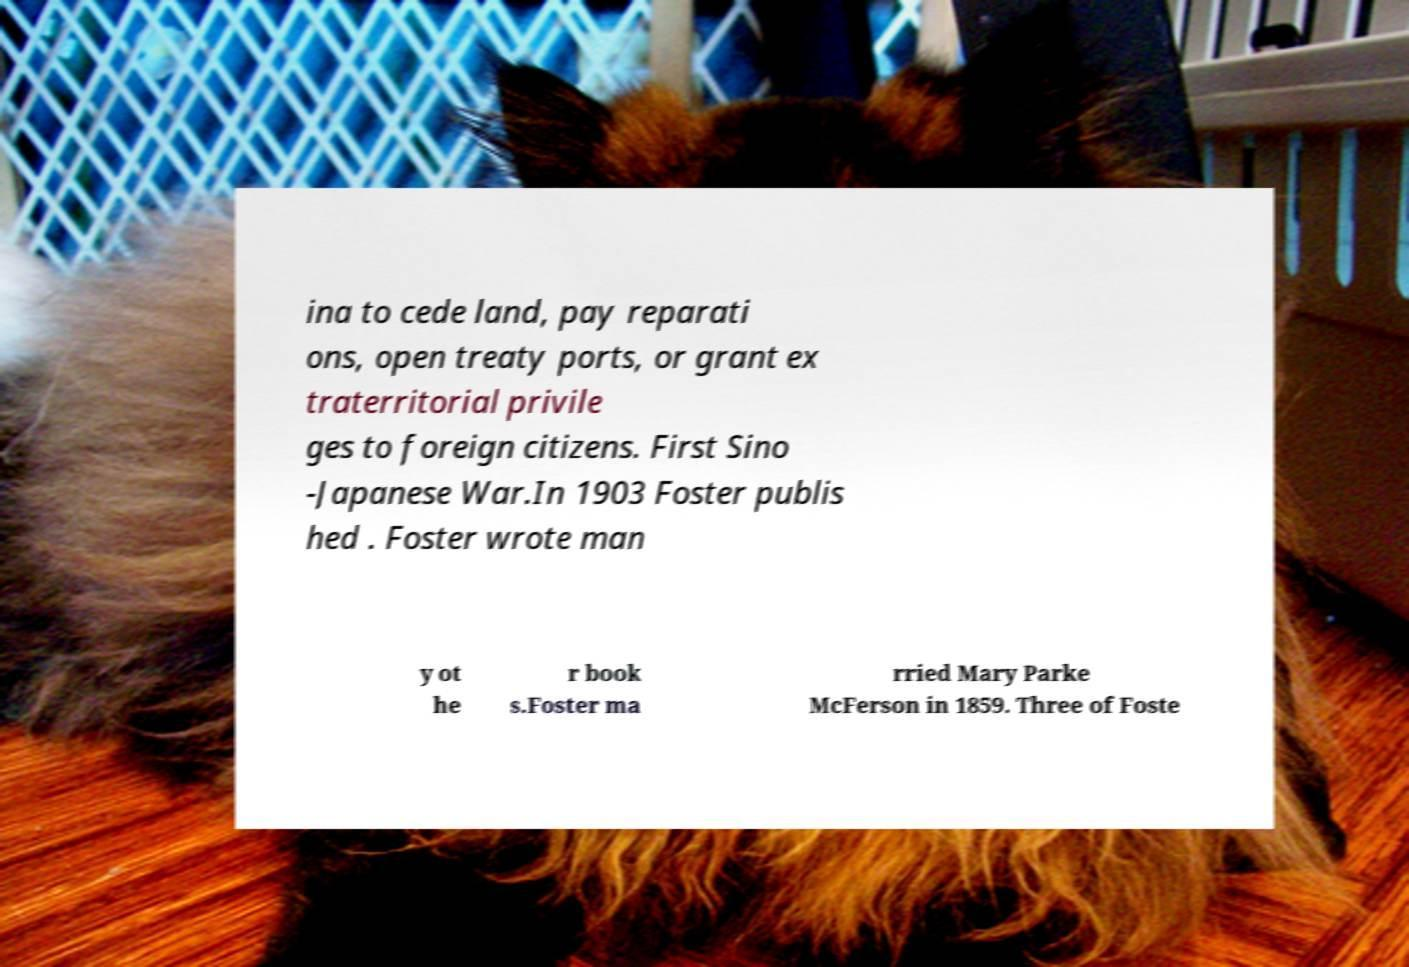Could you assist in decoding the text presented in this image and type it out clearly? ina to cede land, pay reparati ons, open treaty ports, or grant ex traterritorial privile ges to foreign citizens. First Sino -Japanese War.In 1903 Foster publis hed . Foster wrote man y ot he r book s.Foster ma rried Mary Parke McFerson in 1859. Three of Foste 